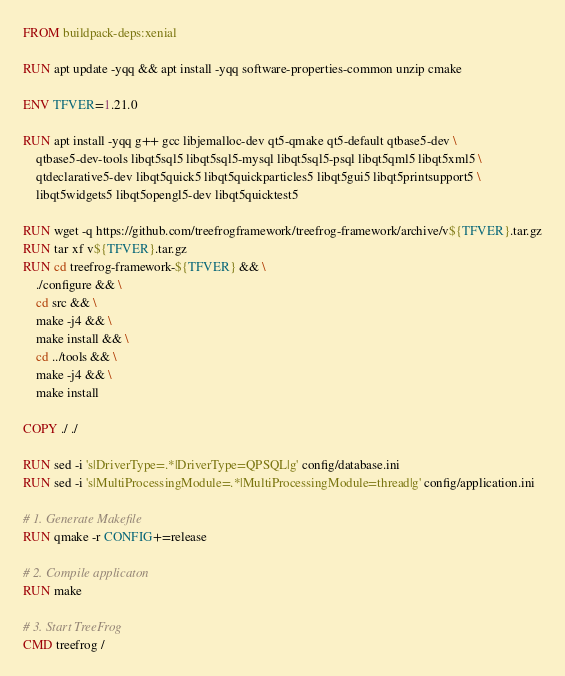Convert code to text. <code><loc_0><loc_0><loc_500><loc_500><_Dockerfile_>FROM buildpack-deps:xenial

RUN apt update -yqq && apt install -yqq software-properties-common unzip cmake

ENV TFVER=1.21.0

RUN apt install -yqq g++ gcc libjemalloc-dev qt5-qmake qt5-default qtbase5-dev \
    qtbase5-dev-tools libqt5sql5 libqt5sql5-mysql libqt5sql5-psql libqt5qml5 libqt5xml5 \
    qtdeclarative5-dev libqt5quick5 libqt5quickparticles5 libqt5gui5 libqt5printsupport5 \
    libqt5widgets5 libqt5opengl5-dev libqt5quicktest5

RUN wget -q https://github.com/treefrogframework/treefrog-framework/archive/v${TFVER}.tar.gz
RUN tar xf v${TFVER}.tar.gz
RUN cd treefrog-framework-${TFVER} && \
    ./configure && \
    cd src && \
    make -j4 && \
    make install && \
    cd ../tools && \
    make -j4 && \
    make install

COPY ./ ./

RUN sed -i 's|DriverType=.*|DriverType=QPSQL|g' config/database.ini
RUN sed -i 's|MultiProcessingModule=.*|MultiProcessingModule=thread|g' config/application.ini

# 1. Generate Makefile
RUN qmake -r CONFIG+=release

# 2. Compile applicaton
RUN make

# 3. Start TreeFrog
CMD treefrog /
</code> 